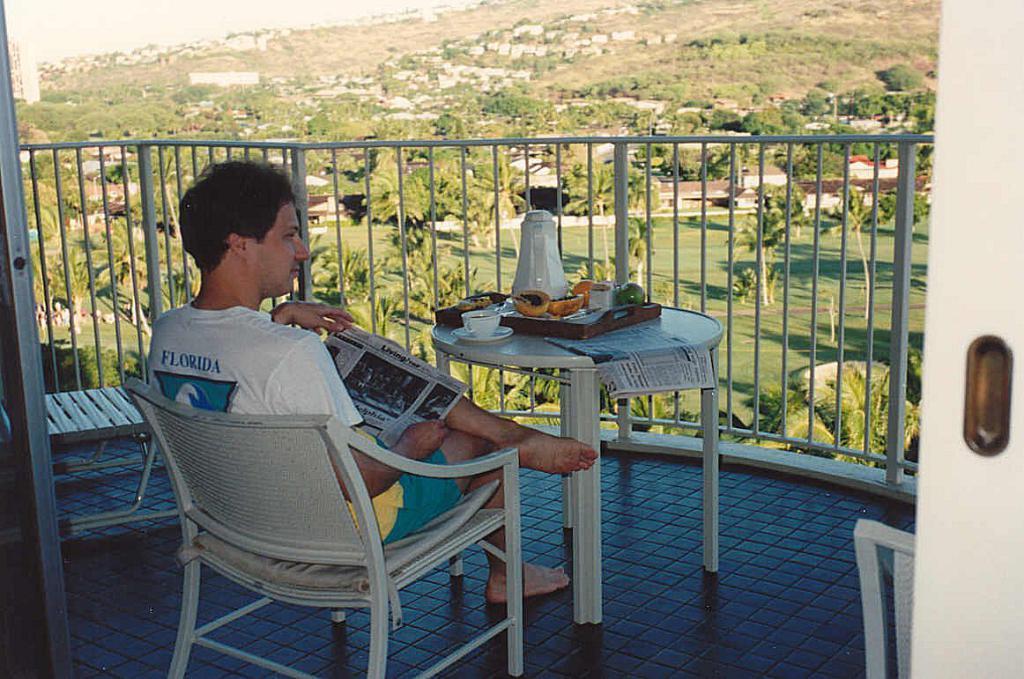Can you describe this image briefly? On the left side of the image we can see a man, he is sitting and he is holding a newspaper, in front of him we can see fence, jug, cup and other things on the table, in the background we can see few trees and houses. 